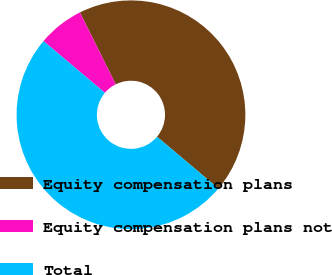<chart> <loc_0><loc_0><loc_500><loc_500><pie_chart><fcel>Equity compensation plans<fcel>Equity compensation plans not<fcel>Total<nl><fcel>43.51%<fcel>6.49%<fcel>50.0%<nl></chart> 